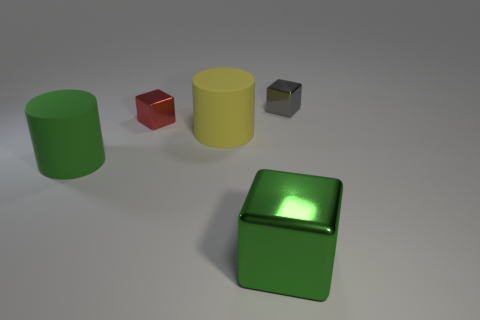Is there a big green metal object of the same shape as the green matte object? While the image does show a green metallic object, there isn't any other large green object in the matte finish with exactly the same shape to compare it directly. However, there are several objects of various shapes and colors present that could be discussed further. 